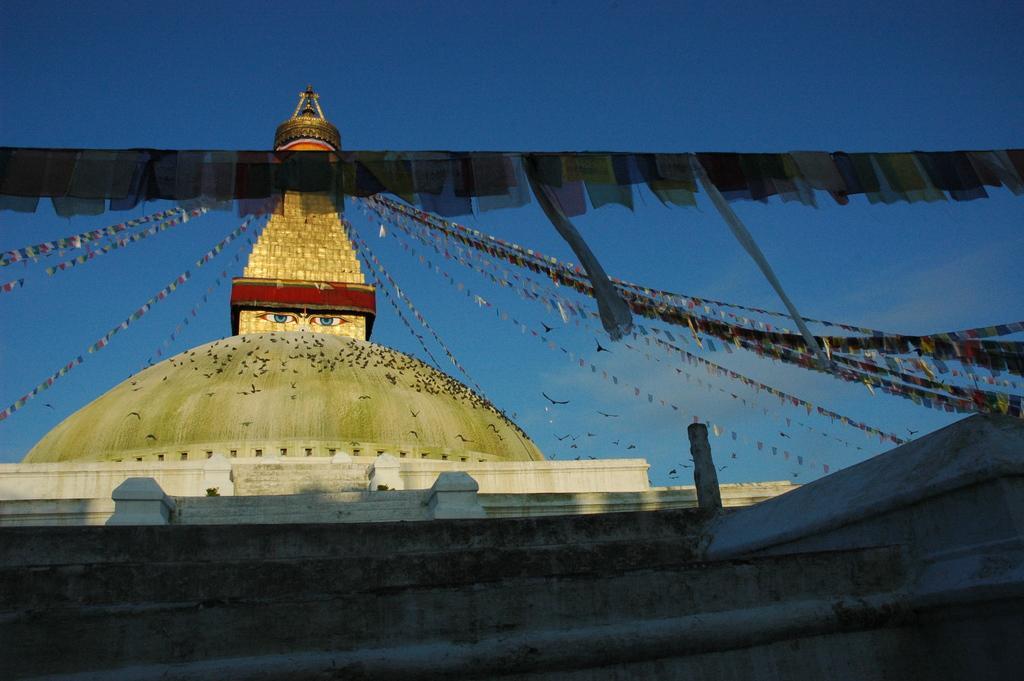Can you describe this image briefly? In this image there is a temple having few birds on it. Few birds are flying in air. Few flags are attached to the building. Two eyes are painted on the wall of building. Top of image there is sky. 